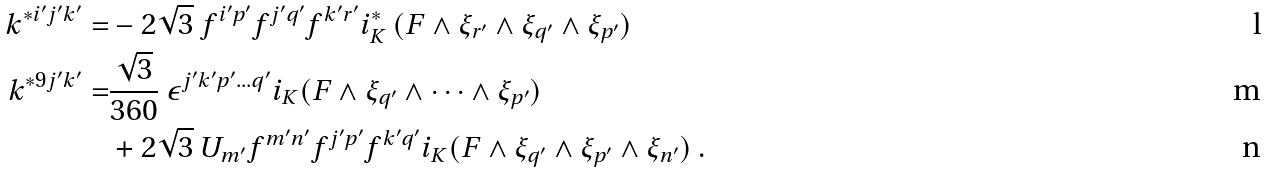<formula> <loc_0><loc_0><loc_500><loc_500>k ^ { * i ^ { \prime } j ^ { \prime } k ^ { \prime } } = & - 2 \sqrt { 3 } \ f ^ { i ^ { \prime } p ^ { \prime } } f ^ { j ^ { \prime } q ^ { \prime } } f ^ { k ^ { \prime } r ^ { \prime } } i _ { K } ^ { * } \, ( F \wedge \xi _ { r ^ { \prime } } \wedge \xi _ { q ^ { \prime } } \wedge \xi _ { p ^ { \prime } } ) \\ k ^ { * 9 j ^ { \prime } k ^ { \prime } } = & \frac { \sqrt { 3 } } { 3 6 0 } \ \epsilon ^ { j ^ { \prime } k ^ { \prime } p ^ { \prime } \dots q ^ { \prime } } i _ { K } ( F \wedge \xi _ { q ^ { \prime } } \wedge \dots \wedge \xi _ { p ^ { \prime } } ) \\ & + 2 \sqrt { 3 } \ U _ { m ^ { \prime } } f ^ { m ^ { \prime } n ^ { \prime } } f ^ { j ^ { \prime } p ^ { \prime } } f ^ { k ^ { \prime } q ^ { \prime } } i _ { K } ( F \wedge \xi _ { q ^ { \prime } } \wedge \xi _ { p ^ { \prime } } \wedge \xi _ { n ^ { \prime } } ) \ .</formula> 